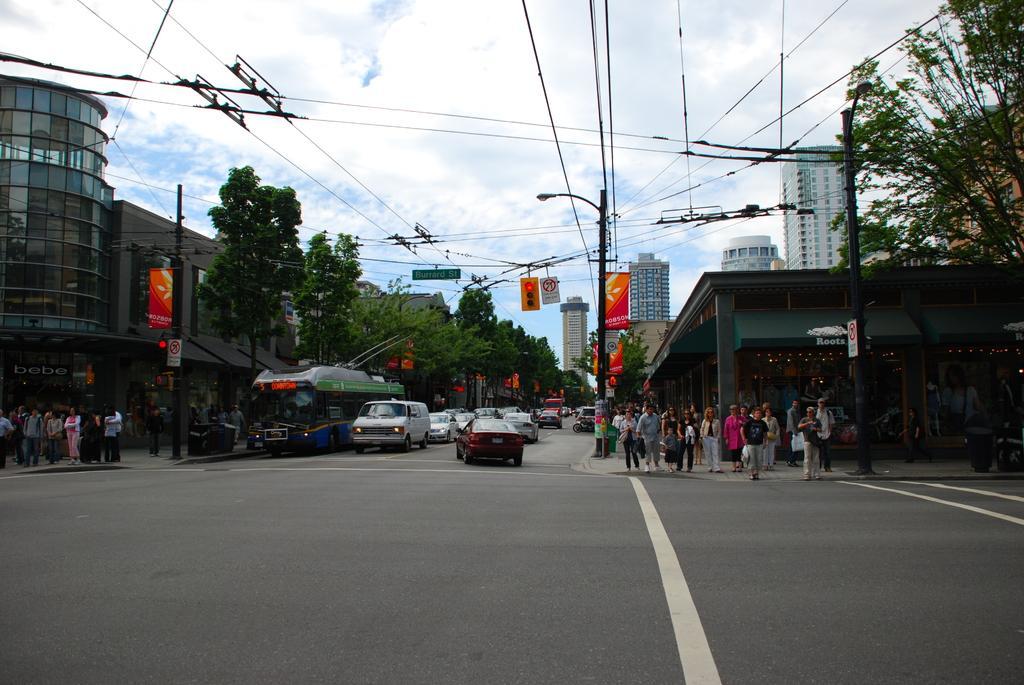How would you summarize this image in a sentence or two? In the background we can see sky with clouds, traffic signals. On either side of the road we can see people and there are vehicles on the road. 